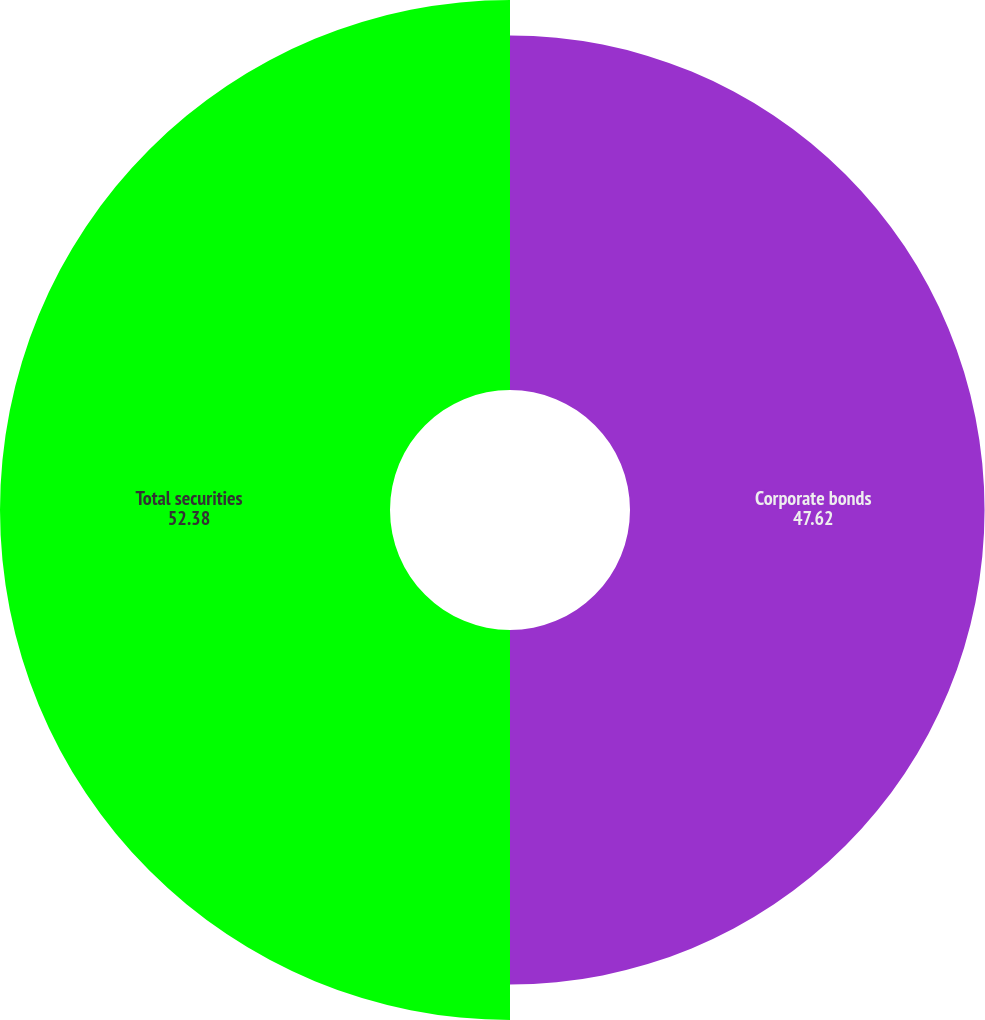<chart> <loc_0><loc_0><loc_500><loc_500><pie_chart><fcel>Corporate bonds<fcel>Total securities<nl><fcel>47.62%<fcel>52.38%<nl></chart> 